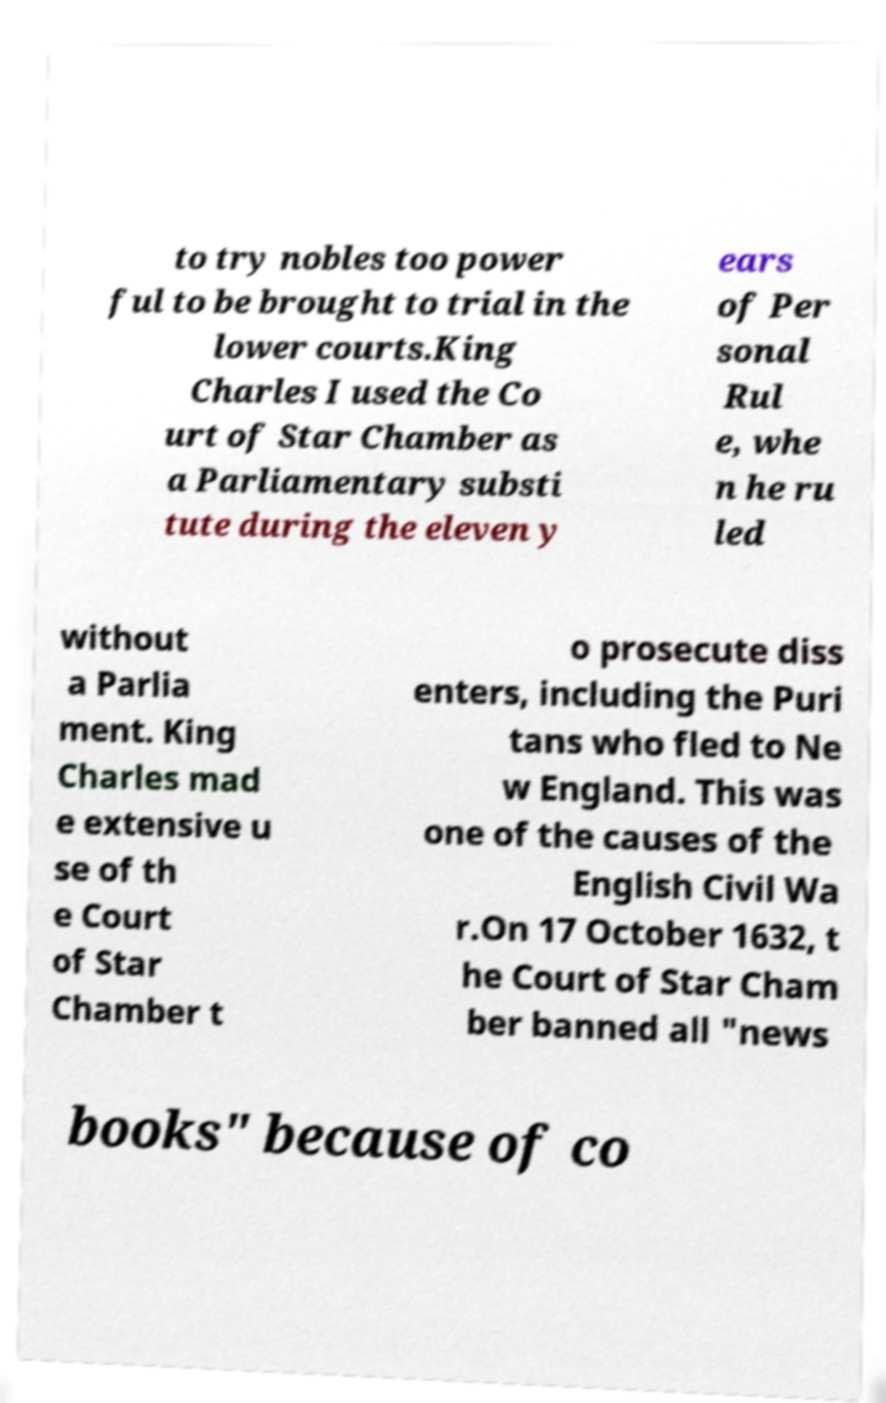What messages or text are displayed in this image? I need them in a readable, typed format. to try nobles too power ful to be brought to trial in the lower courts.King Charles I used the Co urt of Star Chamber as a Parliamentary substi tute during the eleven y ears of Per sonal Rul e, whe n he ru led without a Parlia ment. King Charles mad e extensive u se of th e Court of Star Chamber t o prosecute diss enters, including the Puri tans who fled to Ne w England. This was one of the causes of the English Civil Wa r.On 17 October 1632, t he Court of Star Cham ber banned all "news books" because of co 